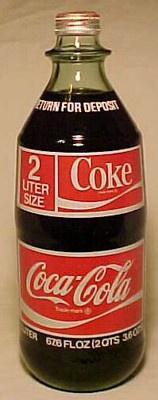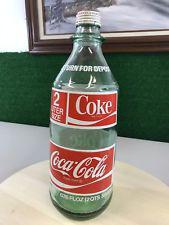The first image is the image on the left, the second image is the image on the right. Analyze the images presented: Is the assertion "The left and right images each feature a single soda bottle with its cap on, and the bottles on the left and right contain the same amount of soda and have similar but not identical labels." valid? Answer yes or no. No. 